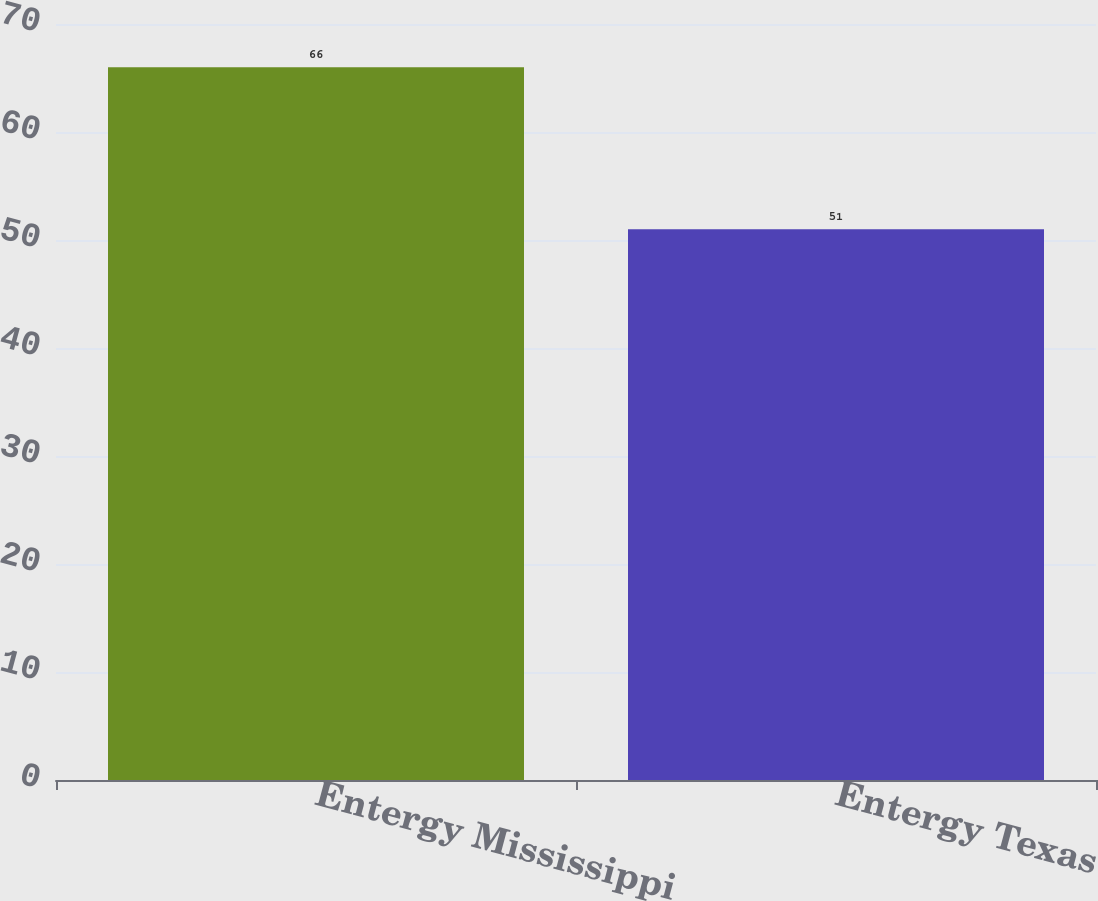Convert chart. <chart><loc_0><loc_0><loc_500><loc_500><bar_chart><fcel>Entergy Mississippi<fcel>Entergy Texas<nl><fcel>66<fcel>51<nl></chart> 